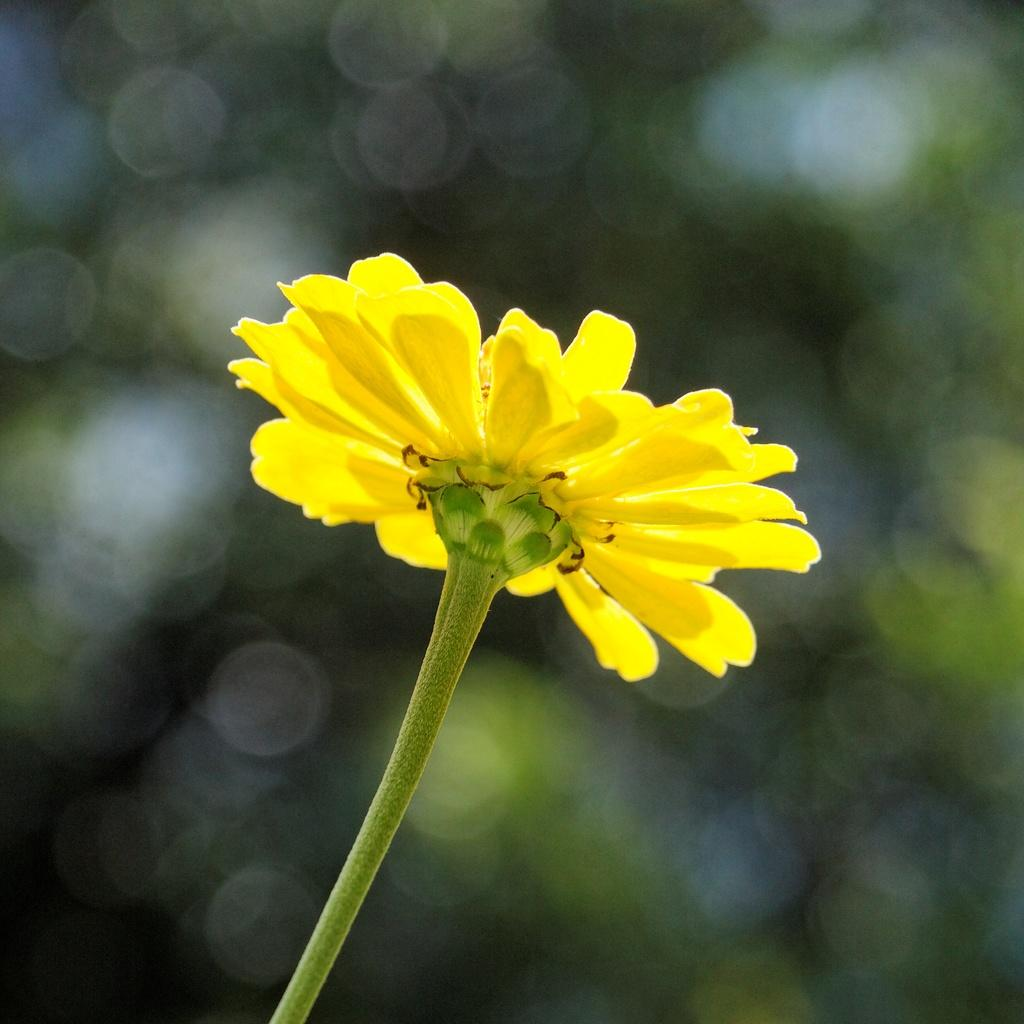What is the main subject of the image? There is a flower in the center of the image. Can you describe the background of the image? The background of the image is blurry. What historical event is depicted in the image? There is no historical event depicted in the image; it features a flower in the center and a blurry background. Can you tell me how many times the wrist is twisted in the image? There is no wrist or any action involving a wrist present in the image. 